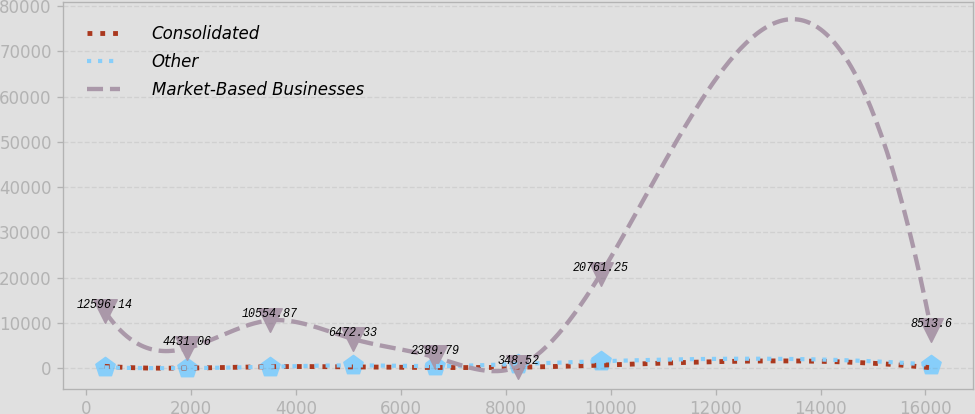Convert chart to OTSL. <chart><loc_0><loc_0><loc_500><loc_500><line_chart><ecel><fcel>Consolidated<fcel>Other<fcel>Market-Based Businesses<nl><fcel>352.36<fcel>401.32<fcel>161.81<fcel>12596.1<nl><fcel>1928.27<fcel>14.67<fcel>10.49<fcel>4431.06<nl><fcel>3504.18<fcel>336.88<fcel>313.13<fcel>10554.9<nl><fcel>5080.09<fcel>272.44<fcel>615.77<fcel>6472.33<nl><fcel>6656<fcel>143.56<fcel>464.45<fcel>2389.79<nl><fcel>8231.91<fcel>208<fcel>918.41<fcel>348.52<nl><fcel>9807.82<fcel>659.12<fcel>1523.7<fcel>20761.2<nl><fcel>16111.5<fcel>79.12<fcel>767.09<fcel>8513.6<nl></chart> 